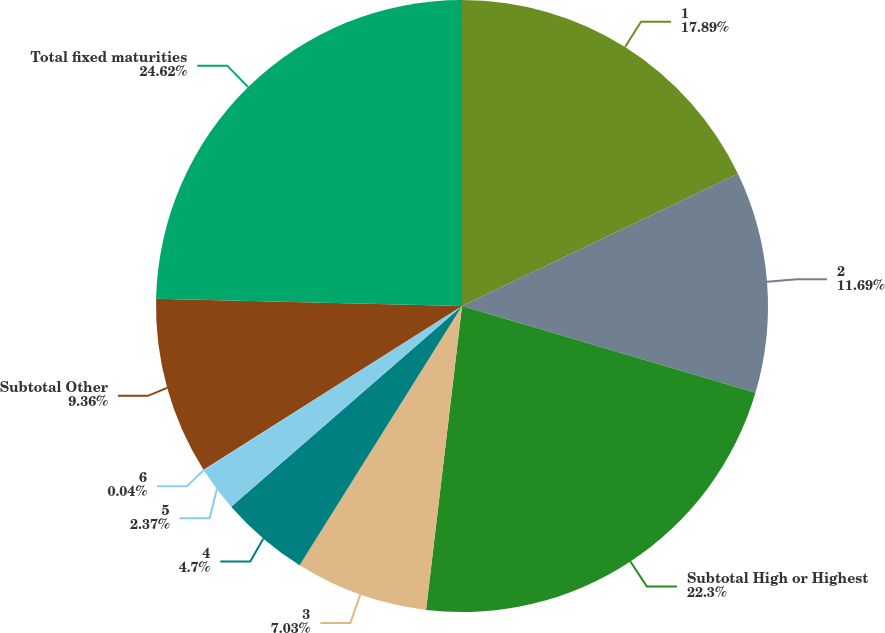Convert chart. <chart><loc_0><loc_0><loc_500><loc_500><pie_chart><fcel>1<fcel>2<fcel>Subtotal High or Highest<fcel>3<fcel>4<fcel>5<fcel>6<fcel>Subtotal Other<fcel>Total fixed maturities<nl><fcel>17.89%<fcel>11.69%<fcel>22.3%<fcel>7.03%<fcel>4.7%<fcel>2.37%<fcel>0.04%<fcel>9.36%<fcel>24.63%<nl></chart> 